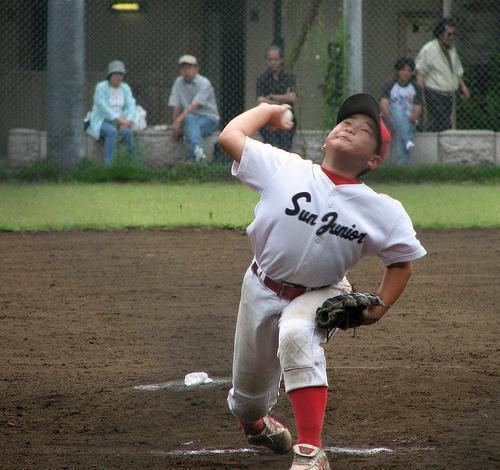How many players are shown?
Give a very brief answer. 1. 